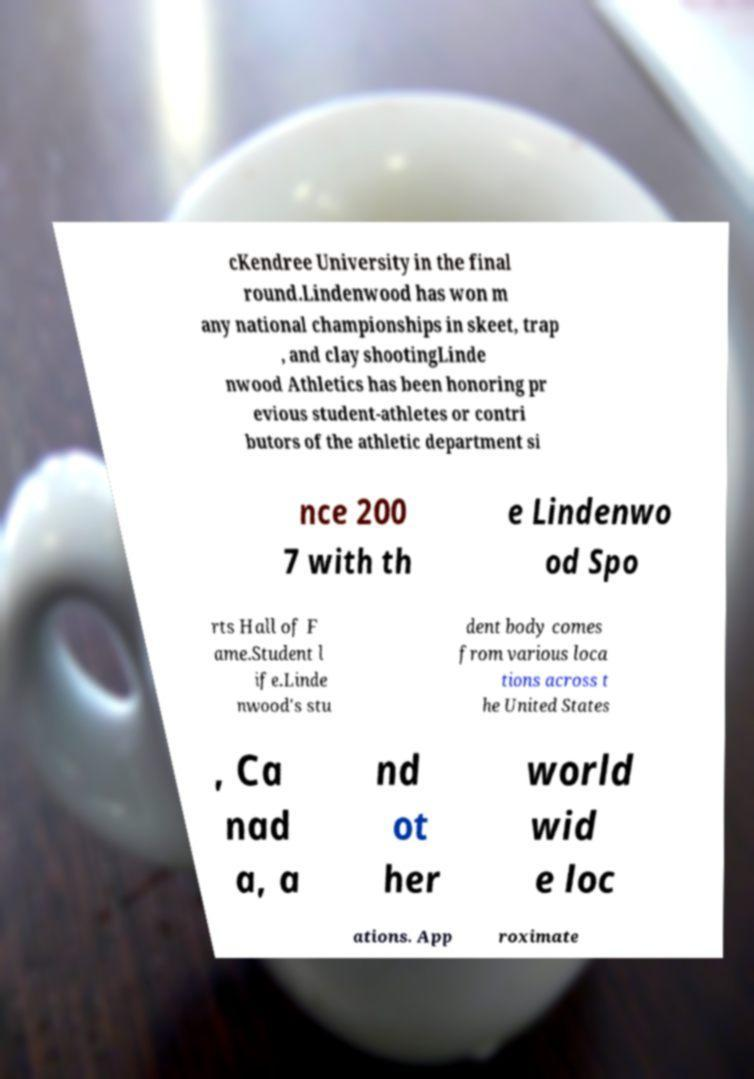Can you accurately transcribe the text from the provided image for me? cKendree University in the final round.Lindenwood has won m any national championships in skeet, trap , and clay shootingLinde nwood Athletics has been honoring pr evious student-athletes or contri butors of the athletic department si nce 200 7 with th e Lindenwo od Spo rts Hall of F ame.Student l ife.Linde nwood's stu dent body comes from various loca tions across t he United States , Ca nad a, a nd ot her world wid e loc ations. App roximate 